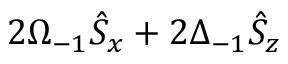Convert formula to latex. <formula><loc_0><loc_0><loc_500><loc_500>2 \Omega _ { - 1 } \hat { S } _ { x } + 2 \Delta _ { - 1 } \hat { S } _ { z }</formula> 